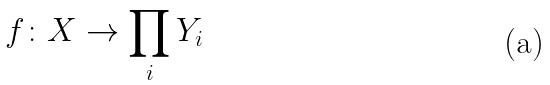Convert formula to latex. <formula><loc_0><loc_0><loc_500><loc_500>f \colon X \rightarrow \prod _ { i } Y _ { i }</formula> 